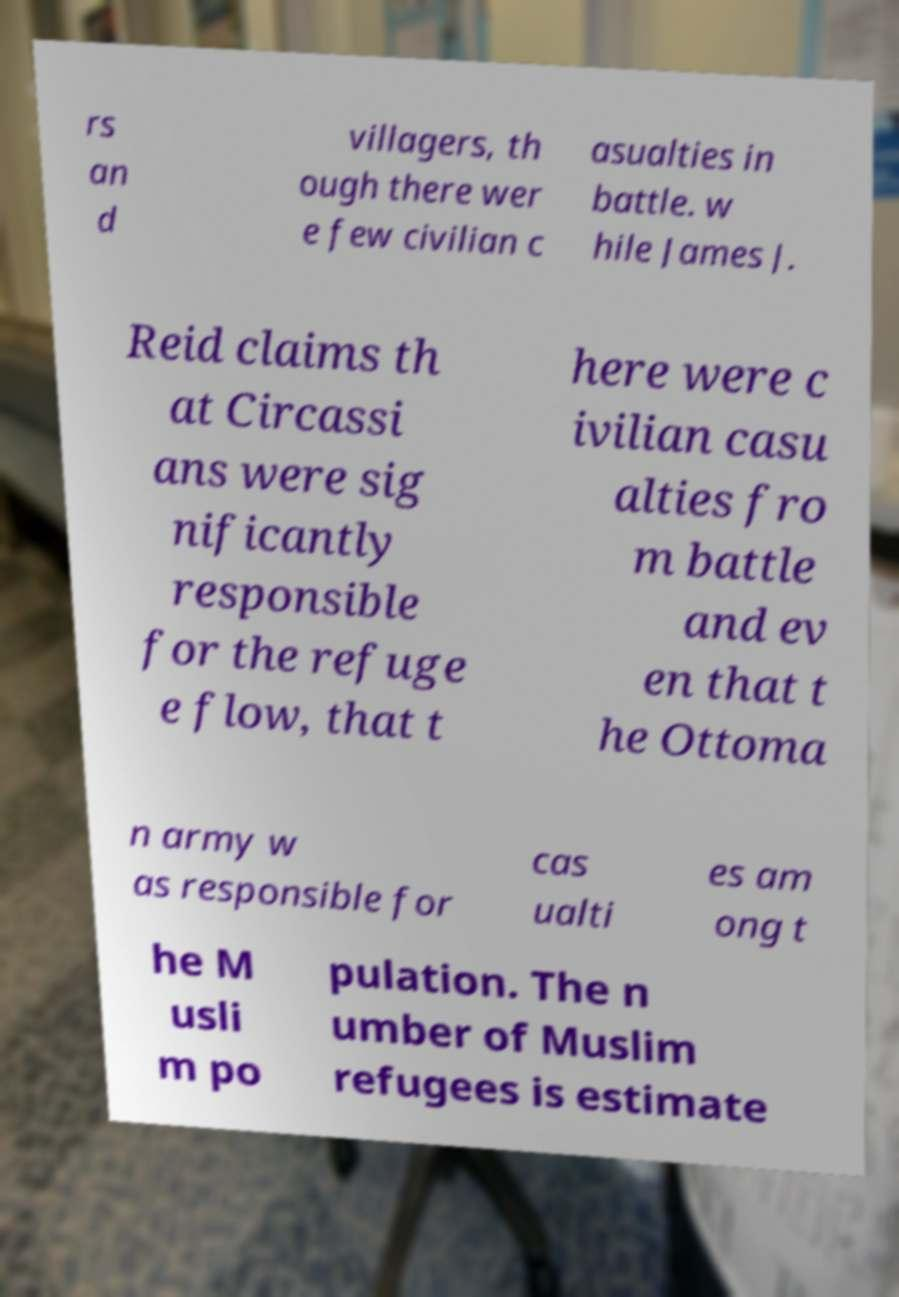Could you assist in decoding the text presented in this image and type it out clearly? rs an d villagers, th ough there wer e few civilian c asualties in battle. w hile James J. Reid claims th at Circassi ans were sig nificantly responsible for the refuge e flow, that t here were c ivilian casu alties fro m battle and ev en that t he Ottoma n army w as responsible for cas ualti es am ong t he M usli m po pulation. The n umber of Muslim refugees is estimate 